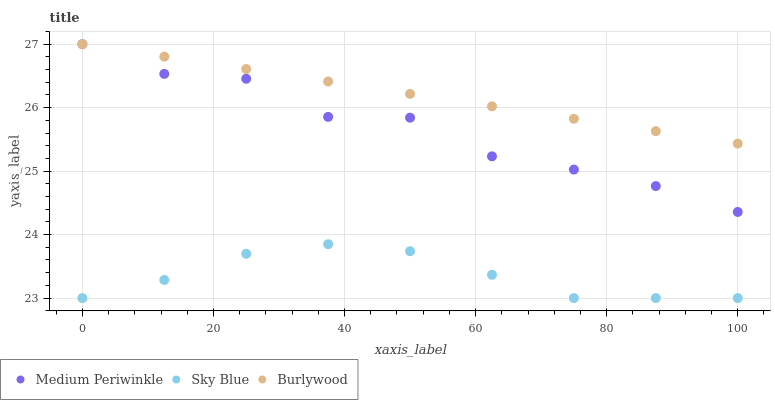Does Sky Blue have the minimum area under the curve?
Answer yes or no. Yes. Does Burlywood have the maximum area under the curve?
Answer yes or no. Yes. Does Medium Periwinkle have the minimum area under the curve?
Answer yes or no. No. Does Medium Periwinkle have the maximum area under the curve?
Answer yes or no. No. Is Burlywood the smoothest?
Answer yes or no. Yes. Is Medium Periwinkle the roughest?
Answer yes or no. Yes. Is Sky Blue the smoothest?
Answer yes or no. No. Is Sky Blue the roughest?
Answer yes or no. No. Does Sky Blue have the lowest value?
Answer yes or no. Yes. Does Medium Periwinkle have the lowest value?
Answer yes or no. No. Does Medium Periwinkle have the highest value?
Answer yes or no. Yes. Does Sky Blue have the highest value?
Answer yes or no. No. Is Sky Blue less than Burlywood?
Answer yes or no. Yes. Is Medium Periwinkle greater than Sky Blue?
Answer yes or no. Yes. Does Medium Periwinkle intersect Burlywood?
Answer yes or no. Yes. Is Medium Periwinkle less than Burlywood?
Answer yes or no. No. Is Medium Periwinkle greater than Burlywood?
Answer yes or no. No. Does Sky Blue intersect Burlywood?
Answer yes or no. No. 